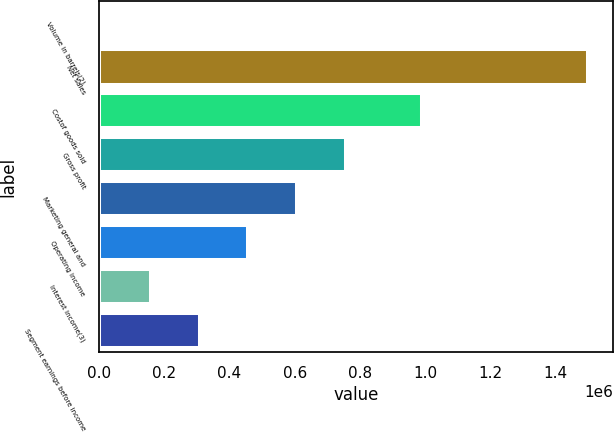<chart> <loc_0><loc_0><loc_500><loc_500><bar_chart><fcel>Volume in barrels(2)<fcel>Net sales<fcel>Costof goods sold<fcel>Gross profit<fcel>Marketing general and<fcel>Operating income<fcel>Interest income(3)<fcel>Segment earnings before income<nl><fcel>10329<fcel>1.5013e+06<fcel>989740<fcel>755814<fcel>606717<fcel>457620<fcel>159426<fcel>308523<nl></chart> 